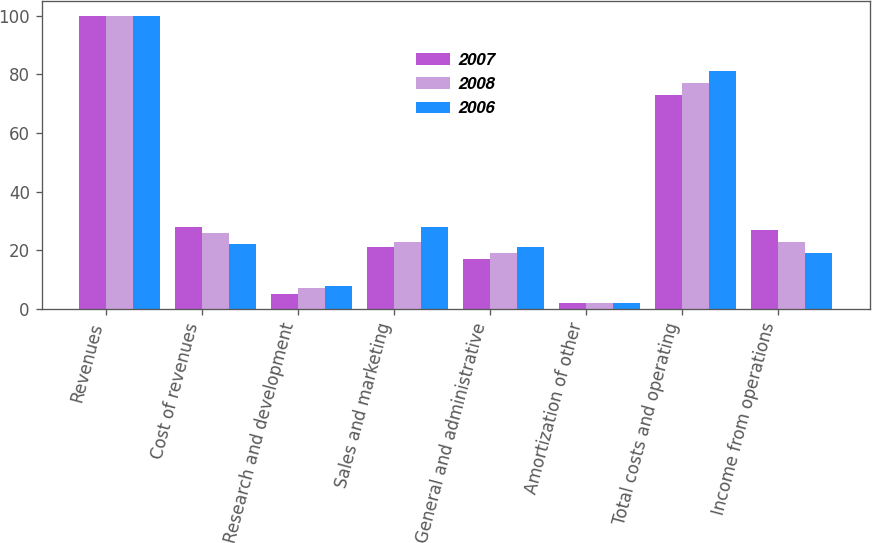Convert chart. <chart><loc_0><loc_0><loc_500><loc_500><stacked_bar_chart><ecel><fcel>Revenues<fcel>Cost of revenues<fcel>Research and development<fcel>Sales and marketing<fcel>General and administrative<fcel>Amortization of other<fcel>Total costs and operating<fcel>Income from operations<nl><fcel>2007<fcel>100<fcel>28<fcel>5<fcel>21<fcel>17<fcel>2<fcel>73<fcel>27<nl><fcel>2008<fcel>100<fcel>26<fcel>7<fcel>23<fcel>19<fcel>2<fcel>77<fcel>23<nl><fcel>2006<fcel>100<fcel>22<fcel>8<fcel>28<fcel>21<fcel>2<fcel>81<fcel>19<nl></chart> 